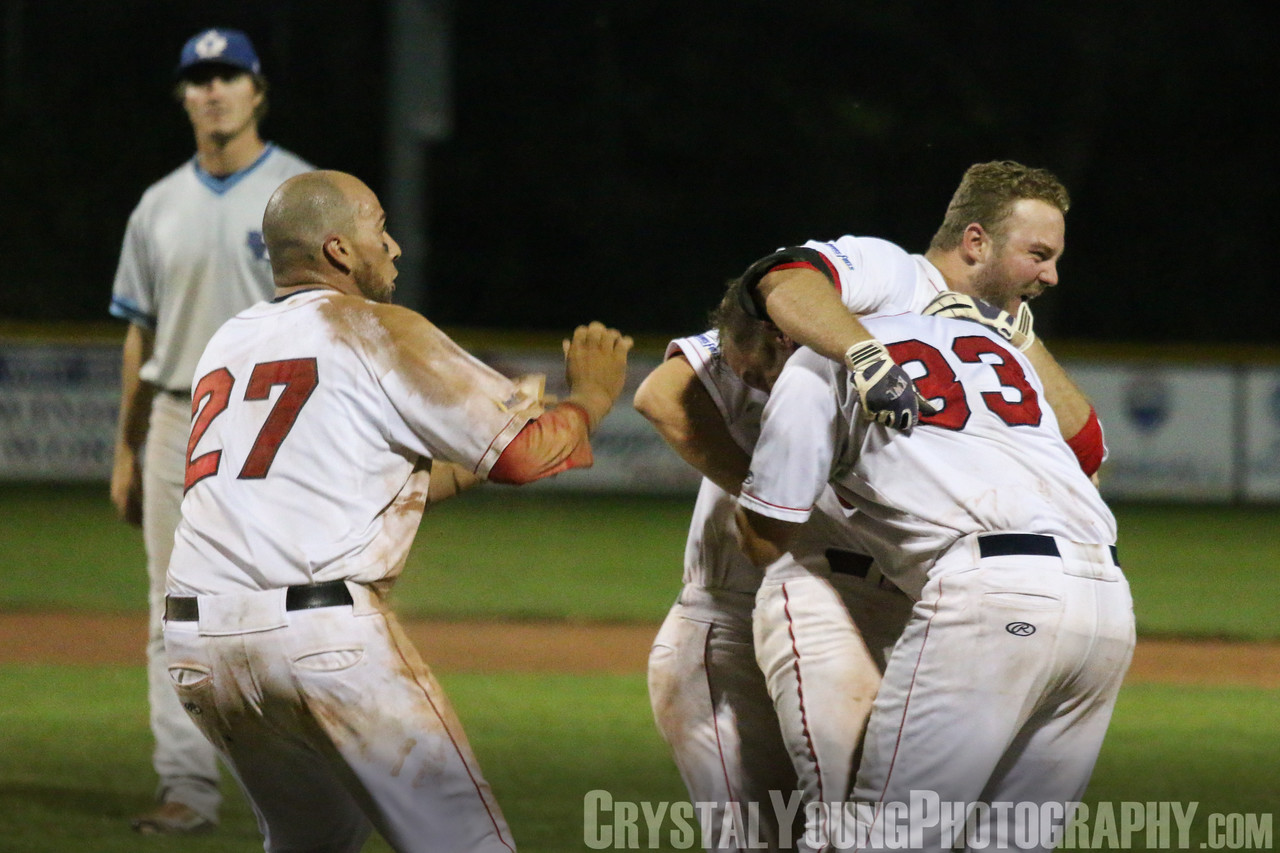What if this celebration marks not just a game victory, but the end of an era? How would that change the context of this image? If this celebration marks the end of an era, such as the final game of a season or the closing chapter of long-time teammates playing together, the image takes on a deeper, more profound significance. The joyous expressions and tight embraces are not just about the victory but also a bittersweet farewell to a shared journey. The players savor each precious second of the moment, fully aware that it will be one of the last times they will celebrate together on the field. The background player's dejection may also be tinged with the added weight of farewell, knowing that this game symbolizes the conclusion of an important period in their lives. This heightened emotional context transforms the image into a poignant, multi-layered story of triumph, camaraderie, and nostalgic closure. 